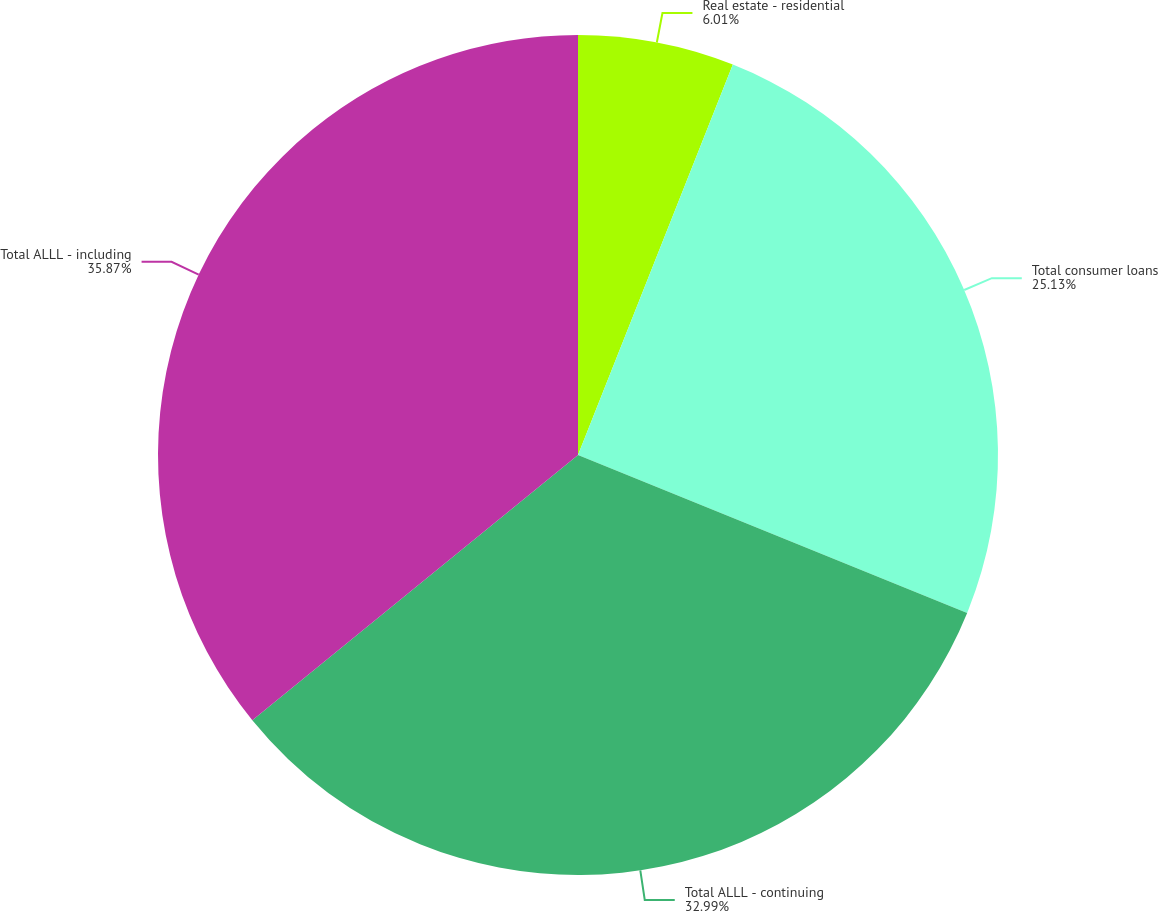Convert chart. <chart><loc_0><loc_0><loc_500><loc_500><pie_chart><fcel>Real estate - residential<fcel>Total consumer loans<fcel>Total ALLL - continuing<fcel>Total ALLL - including<nl><fcel>6.01%<fcel>25.13%<fcel>32.99%<fcel>35.88%<nl></chart> 